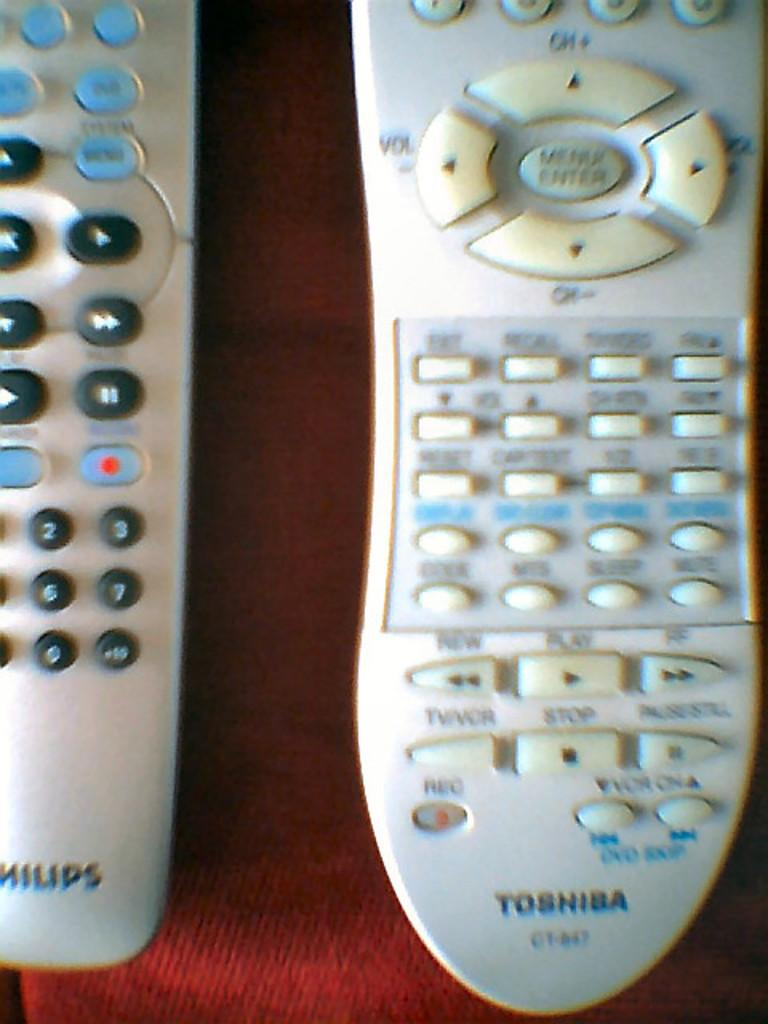<image>
Provide a brief description of the given image. Two white old style remote controls, one toshiba the other philips, lay next to each other. 